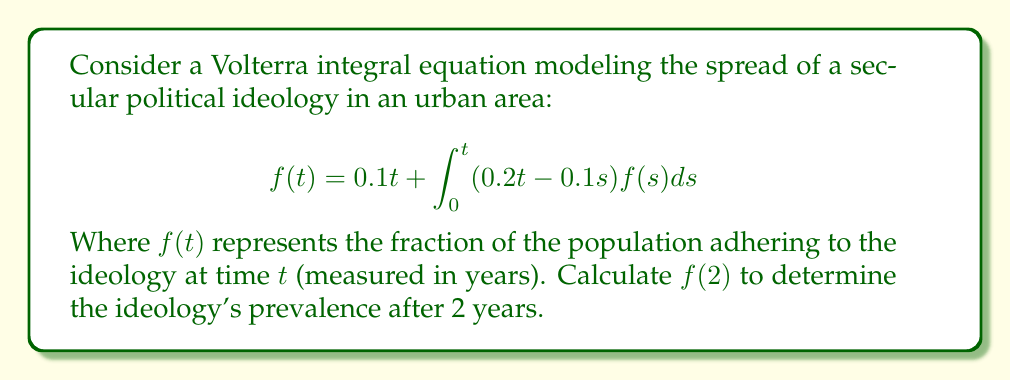Could you help me with this problem? To solve this Volterra integral equation and find $f(2)$, we'll use the method of successive approximations:

1) Start with the initial approximation $f_0(t) = 0.1t$

2) Substitute this into the right-hand side of the equation to get $f_1(t)$:

   $$f_1(t) = 0.1t + \int_0^t (0.2t - 0.1s)(0.1s)ds$$

3) Evaluate the integral:
   
   $$f_1(t) = 0.1t + 0.02t\int_0^t sds - 0.01\int_0^t s^2ds$$
   $$f_1(t) = 0.1t + 0.02t(\frac{t^2}{2}) - 0.01(\frac{t^3}{3})$$
   $$f_1(t) = 0.1t + 0.01t^3 - \frac{0.01t^3}{3} = 0.1t + \frac{0.02t^3}{3}$$

4) Now use $f_1(t)$ to find $f_2(t)$:

   $$f_2(t) = 0.1t + \int_0^t (0.2t - 0.1s)(0.1s + \frac{0.02s^3}{3})ds$$

5) Evaluate this integral (omitting intermediate steps for brevity):

   $$f_2(t) = 0.1t + 0.01t^3 - \frac{0.01t^3}{3} + \frac{0.004t^5}{15} - \frac{0.0004t^5}{15}$$
   $$f_2(t) = 0.1t + \frac{0.02t^3}{3} + \frac{0.002t^5}{5}$$

6) Calculate $f_2(2)$:

   $$f_2(2) = 0.1(2) + \frac{0.02(2^3)}{3} + \frac{0.002(2^5)}{5}$$
   $$f_2(2) = 0.2 + \frac{0.16}{3} + \frac{0.064}{5} = 0.2 + 0.05333... + 0.0128 = 0.26613...$$

This approximation is reasonably accurate for our purposes.
Answer: $f(2) \approx 0.2661$ 